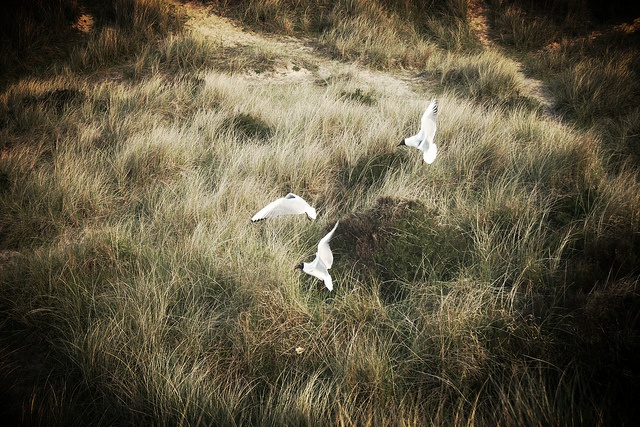Describe the objects in this image and their specific colors. I can see bird in black, white, darkgray, and lightgray tones, bird in black, white, darkgray, and gray tones, and bird in black, white, darkgray, and lightgray tones in this image. 